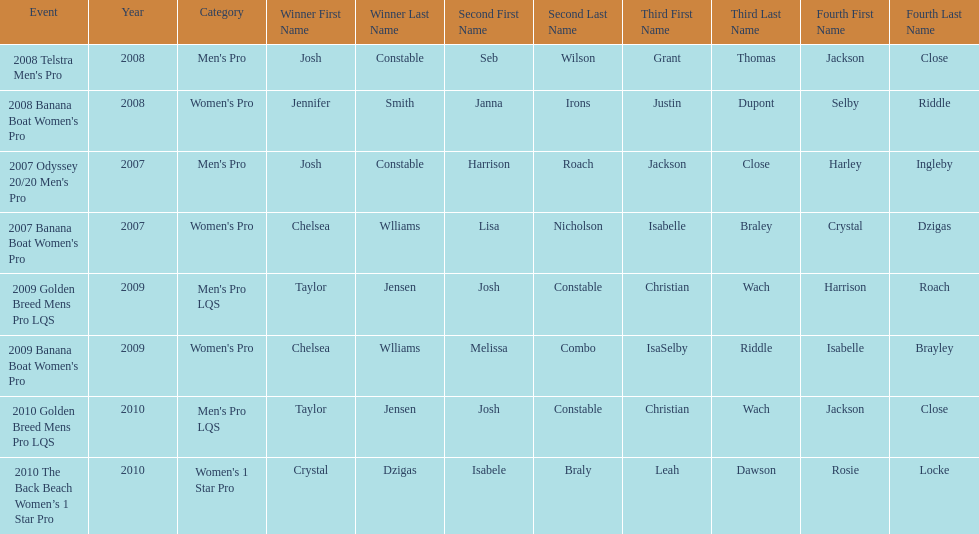Name each of the years that taylor jensen was winner. 2009, 2010. 